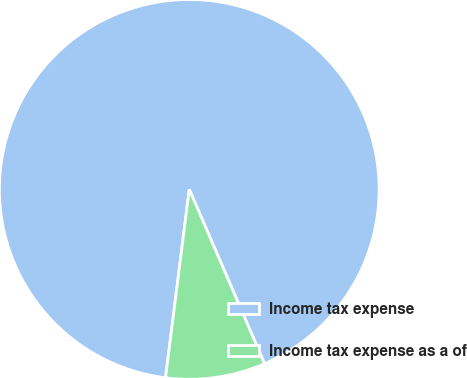<chart> <loc_0><loc_0><loc_500><loc_500><pie_chart><fcel>Income tax expense<fcel>Income tax expense as a of<nl><fcel>91.52%<fcel>8.48%<nl></chart> 